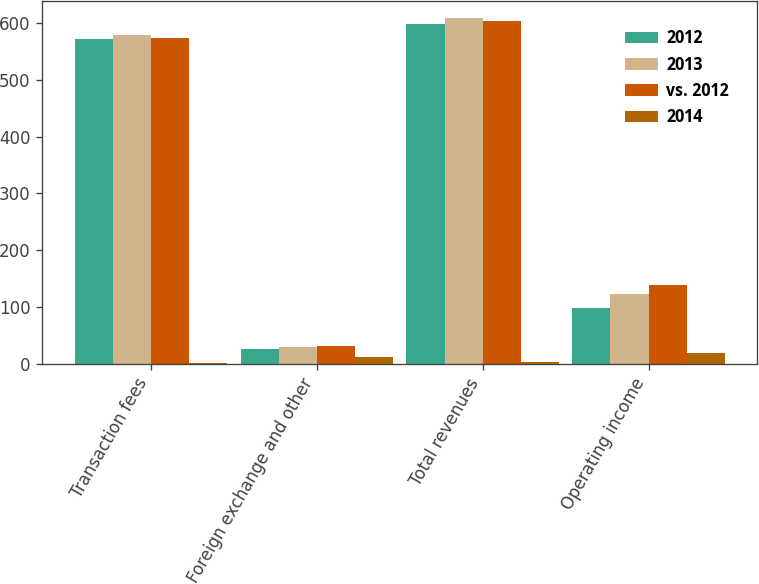Convert chart to OTSL. <chart><loc_0><loc_0><loc_500><loc_500><stacked_bar_chart><ecel><fcel>Transaction fees<fcel>Foreign exchange and other<fcel>Total revenues<fcel>Operating income<nl><fcel>2012<fcel>572.7<fcel>26.1<fcel>598.8<fcel>98.7<nl><fcel>2013<fcel>579.1<fcel>29.4<fcel>608.5<fcel>121.9<nl><fcel>vs. 2012<fcel>573.6<fcel>30.3<fcel>603.9<fcel>137.6<nl><fcel>2014<fcel>1<fcel>11<fcel>2<fcel>19<nl></chart> 